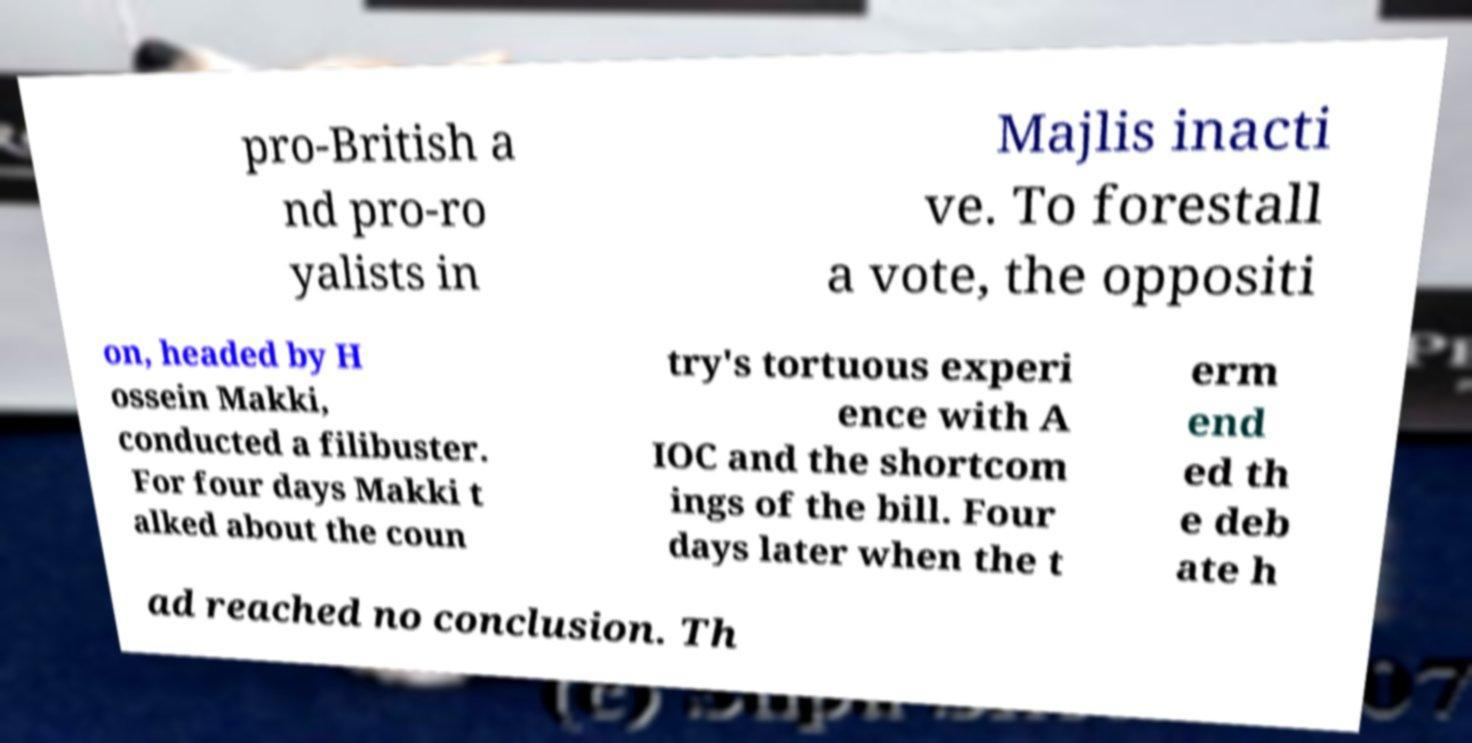Please read and relay the text visible in this image. What does it say? pro-British a nd pro-ro yalists in Majlis inacti ve. To forestall a vote, the oppositi on, headed by H ossein Makki, conducted a filibuster. For four days Makki t alked about the coun try's tortuous experi ence with A IOC and the shortcom ings of the bill. Four days later when the t erm end ed th e deb ate h ad reached no conclusion. Th 